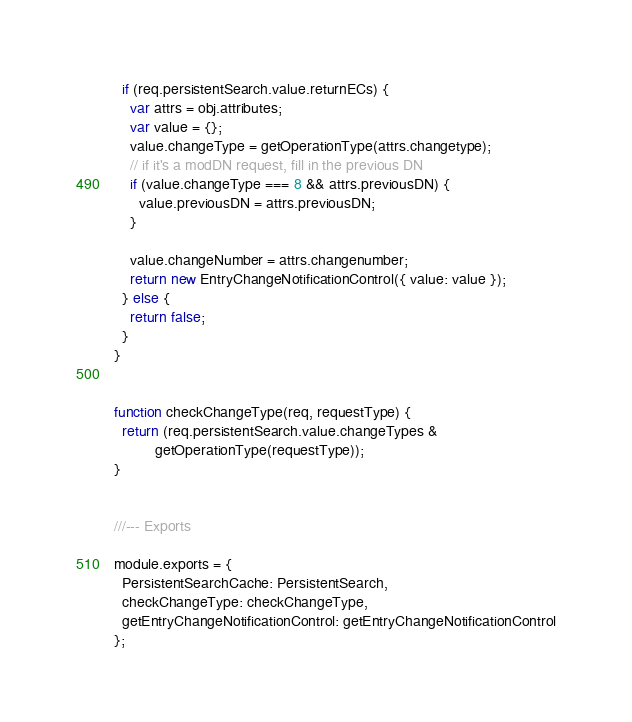<code> <loc_0><loc_0><loc_500><loc_500><_JavaScript_>  if (req.persistentSearch.value.returnECs) {
    var attrs = obj.attributes;
    var value = {};
    value.changeType = getOperationType(attrs.changetype);
    // if it's a modDN request, fill in the previous DN
    if (value.changeType === 8 && attrs.previousDN) {
      value.previousDN = attrs.previousDN;
    }

    value.changeNumber = attrs.changenumber;
    return new EntryChangeNotificationControl({ value: value });
  } else {
    return false;
  }
}


function checkChangeType(req, requestType) {
  return (req.persistentSearch.value.changeTypes &
          getOperationType(requestType));
}


///--- Exports

module.exports = {
  PersistentSearchCache: PersistentSearch,
  checkChangeType: checkChangeType,
  getEntryChangeNotificationControl: getEntryChangeNotificationControl
};
</code> 